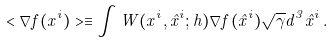Convert formula to latex. <formula><loc_0><loc_0><loc_500><loc_500>< \nabla f ( x ^ { i } ) > \equiv \int W ( x ^ { i } , \hat { x } ^ { i } ; h ) \nabla f ( \hat { x } ^ { i } ) \sqrt { \gamma } d ^ { 3 } \hat { x } ^ { i } \, .</formula> 